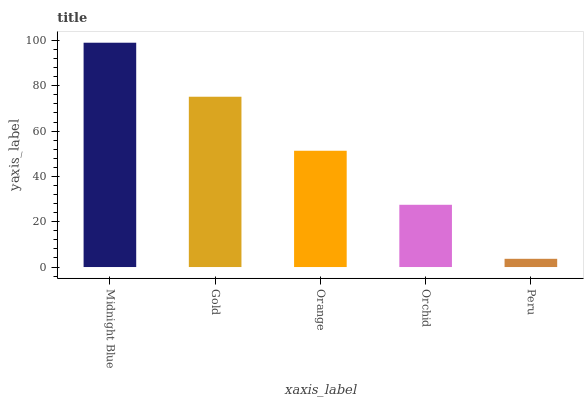Is Peru the minimum?
Answer yes or no. Yes. Is Midnight Blue the maximum?
Answer yes or no. Yes. Is Gold the minimum?
Answer yes or no. No. Is Gold the maximum?
Answer yes or no. No. Is Midnight Blue greater than Gold?
Answer yes or no. Yes. Is Gold less than Midnight Blue?
Answer yes or no. Yes. Is Gold greater than Midnight Blue?
Answer yes or no. No. Is Midnight Blue less than Gold?
Answer yes or no. No. Is Orange the high median?
Answer yes or no. Yes. Is Orange the low median?
Answer yes or no. Yes. Is Midnight Blue the high median?
Answer yes or no. No. Is Peru the low median?
Answer yes or no. No. 